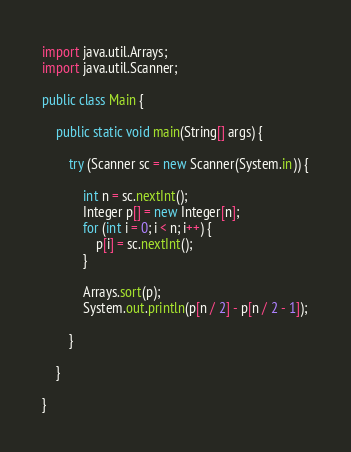Convert code to text. <code><loc_0><loc_0><loc_500><loc_500><_Java_>import java.util.Arrays;
import java.util.Scanner;

public class Main {

	public static void main(String[] args) {

		try (Scanner sc = new Scanner(System.in)) {

			int n = sc.nextInt();
			Integer p[] = new Integer[n];
			for (int i = 0; i < n; i++) {
				p[i] = sc.nextInt();
			}

			Arrays.sort(p);
			System.out.println(p[n / 2] - p[n / 2 - 1]);

		}

	}

}</code> 